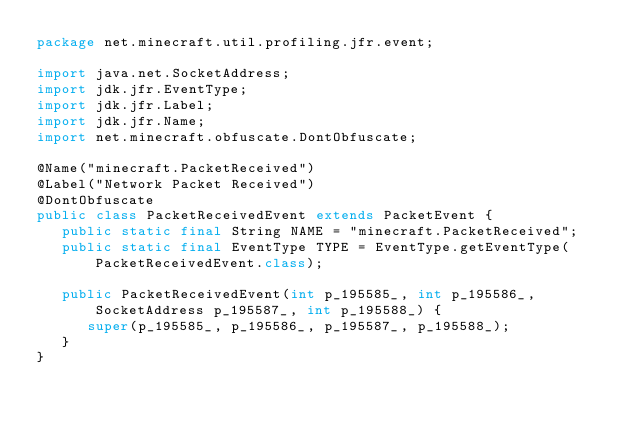<code> <loc_0><loc_0><loc_500><loc_500><_Java_>package net.minecraft.util.profiling.jfr.event;

import java.net.SocketAddress;
import jdk.jfr.EventType;
import jdk.jfr.Label;
import jdk.jfr.Name;
import net.minecraft.obfuscate.DontObfuscate;

@Name("minecraft.PacketReceived")
@Label("Network Packet Received")
@DontObfuscate
public class PacketReceivedEvent extends PacketEvent {
   public static final String NAME = "minecraft.PacketReceived";
   public static final EventType TYPE = EventType.getEventType(PacketReceivedEvent.class);

   public PacketReceivedEvent(int p_195585_, int p_195586_, SocketAddress p_195587_, int p_195588_) {
      super(p_195585_, p_195586_, p_195587_, p_195588_);
   }
}</code> 